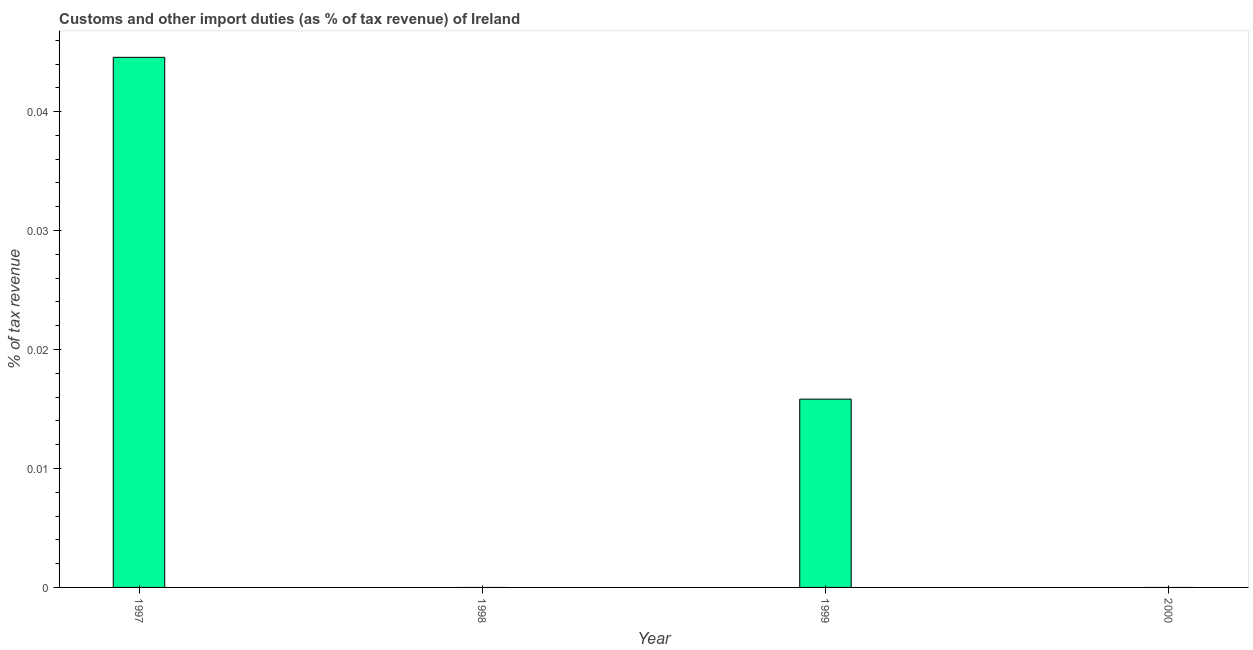Does the graph contain any zero values?
Keep it short and to the point. Yes. What is the title of the graph?
Your answer should be very brief. Customs and other import duties (as % of tax revenue) of Ireland. What is the label or title of the X-axis?
Give a very brief answer. Year. What is the label or title of the Y-axis?
Offer a very short reply. % of tax revenue. What is the customs and other import duties in 2000?
Your answer should be compact. 0. Across all years, what is the maximum customs and other import duties?
Provide a short and direct response. 0.04. What is the sum of the customs and other import duties?
Give a very brief answer. 0.06. What is the average customs and other import duties per year?
Give a very brief answer. 0.01. What is the median customs and other import duties?
Your answer should be compact. 0.01. In how many years, is the customs and other import duties greater than 0.036 %?
Your answer should be compact. 1. Is the sum of the customs and other import duties in 1997 and 1999 greater than the maximum customs and other import duties across all years?
Your answer should be very brief. Yes. In how many years, is the customs and other import duties greater than the average customs and other import duties taken over all years?
Give a very brief answer. 2. How many years are there in the graph?
Make the answer very short. 4. What is the difference between two consecutive major ticks on the Y-axis?
Offer a very short reply. 0.01. Are the values on the major ticks of Y-axis written in scientific E-notation?
Keep it short and to the point. No. What is the % of tax revenue of 1997?
Offer a terse response. 0.04. What is the % of tax revenue of 1998?
Give a very brief answer. 0. What is the % of tax revenue of 1999?
Make the answer very short. 0.02. What is the difference between the % of tax revenue in 1997 and 1999?
Provide a succinct answer. 0.03. What is the ratio of the % of tax revenue in 1997 to that in 1999?
Offer a terse response. 2.81. 